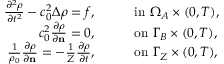Convert formula to latex. <formula><loc_0><loc_0><loc_500><loc_500>\begin{array} { r l } { \frac { \partial ^ { 2 } \rho } { \partial t ^ { 2 } } - c _ { 0 } ^ { 2 } \Delta \rho = f , } & { \quad i n \Omega _ { A } \times ( 0 , T ) , } \\ { c _ { 0 } ^ { 2 } \frac { \partial \rho } { \partial n } = 0 , } & { \quad o n \Gamma _ { B } \times ( 0 , T ) , } \\ { \frac { 1 } { \rho _ { 0 } } \frac { \partial \rho } { \partial n } = - \frac { 1 } { Z } \frac { \partial \rho } { \partial t } , } & { \quad o n \Gamma _ { Z } \times ( 0 , T ) , } \end{array}</formula> 